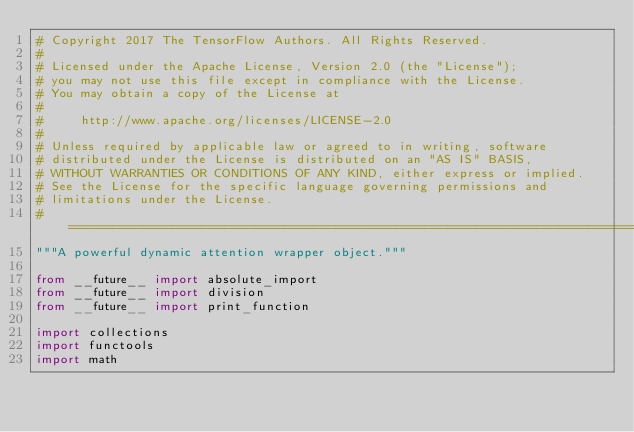<code> <loc_0><loc_0><loc_500><loc_500><_Python_># Copyright 2017 The TensorFlow Authors. All Rights Reserved.
#
# Licensed under the Apache License, Version 2.0 (the "License");
# you may not use this file except in compliance with the License.
# You may obtain a copy of the License at
#
#     http://www.apache.org/licenses/LICENSE-2.0
#
# Unless required by applicable law or agreed to in writing, software
# distributed under the License is distributed on an "AS IS" BASIS,
# WITHOUT WARRANTIES OR CONDITIONS OF ANY KIND, either express or implied.
# See the License for the specific language governing permissions and
# limitations under the License.
# ==============================================================================
"""A powerful dynamic attention wrapper object."""

from __future__ import absolute_import
from __future__ import division
from __future__ import print_function

import collections
import functools
import math
</code> 